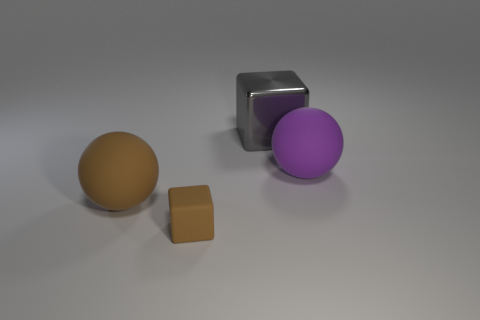Is there any other thing that has the same material as the gray block?
Ensure brevity in your answer.  No. There is a tiny rubber object; is it the same shape as the large matte thing that is on the right side of the small block?
Provide a succinct answer. No. How many other objects are there of the same size as the gray object?
Provide a succinct answer. 2. What number of red objects are large balls or tiny matte blocks?
Make the answer very short. 0. How many matte things are on the left side of the big purple rubber ball and to the right of the tiny block?
Your answer should be compact. 0. What is the object in front of the matte sphere on the left side of the big matte ball on the right side of the large brown matte ball made of?
Your response must be concise. Rubber. What number of big purple objects have the same material as the large purple ball?
Provide a short and direct response. 0. The object that is the same color as the small block is what shape?
Provide a succinct answer. Sphere. There is a purple object that is the same size as the metallic block; what shape is it?
Your answer should be very brief. Sphere. Are there any large gray blocks in front of the small brown rubber object?
Your answer should be compact. No. 